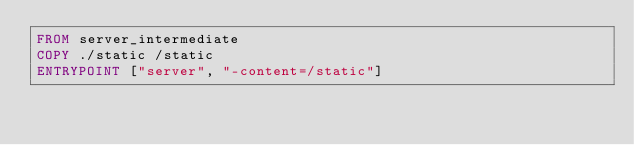Convert code to text. <code><loc_0><loc_0><loc_500><loc_500><_Dockerfile_>FROM server_intermediate
COPY ./static /static
ENTRYPOINT ["server", "-content=/static"]
</code> 